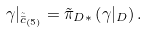<formula> <loc_0><loc_0><loc_500><loc_500>\gamma | _ { \tilde { \bar { c } } _ { ( { \bar { 5 } ) } } } = \tilde { \pi } _ { D * } \left ( \gamma | _ { D } \right ) .</formula> 